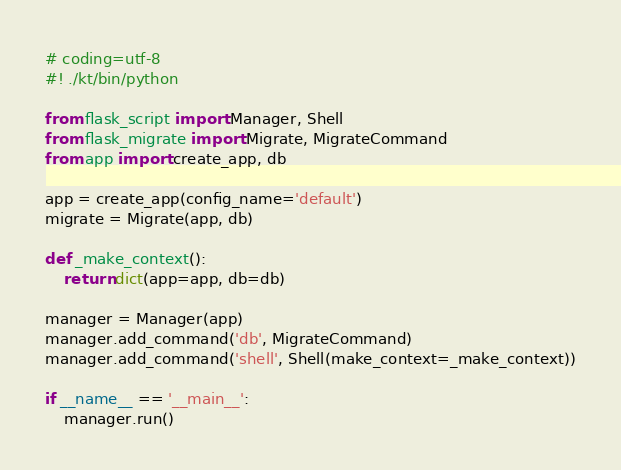<code> <loc_0><loc_0><loc_500><loc_500><_Python_># coding=utf-8
#! ./kt/bin/python

from flask_script import Manager, Shell
from flask_migrate import Migrate, MigrateCommand
from app import create_app, db

app = create_app(config_name='default')
migrate = Migrate(app, db)

def _make_context():
    return dict(app=app, db=db)

manager = Manager(app)
manager.add_command('db', MigrateCommand)
manager.add_command('shell', Shell(make_context=_make_context))

if __name__ == '__main__':
    manager.run()
</code> 